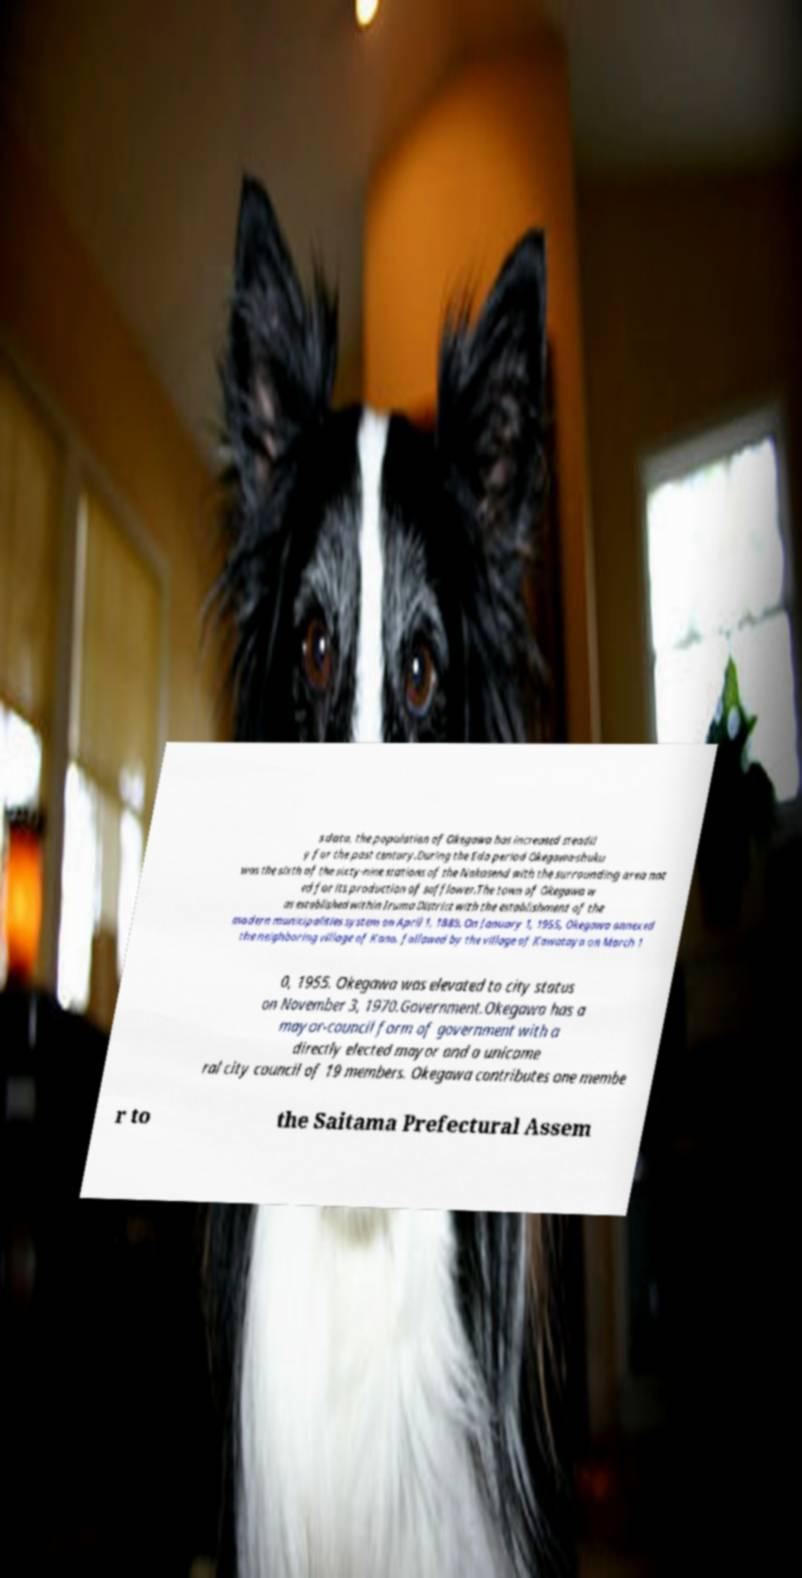For documentation purposes, I need the text within this image transcribed. Could you provide that? s data, the population of Okegawa has increased steadil y for the past century.During the Edo period Okegawa-shuku was the sixth of the sixty-nine stations of the Nakasend with the surrounding area not ed for its production of safflower.The town of Okegawa w as established within Iruma District with the establishment of the modern municipalities system on April 1, 1889. On January 1, 1955, Okegawa annexed the neighboring village of Kano, followed by the village of Kawataya on March 1 0, 1955. Okegawa was elevated to city status on November 3, 1970.Government.Okegawa has a mayor-council form of government with a directly elected mayor and a unicame ral city council of 19 members. Okegawa contributes one membe r to the Saitama Prefectural Assem 